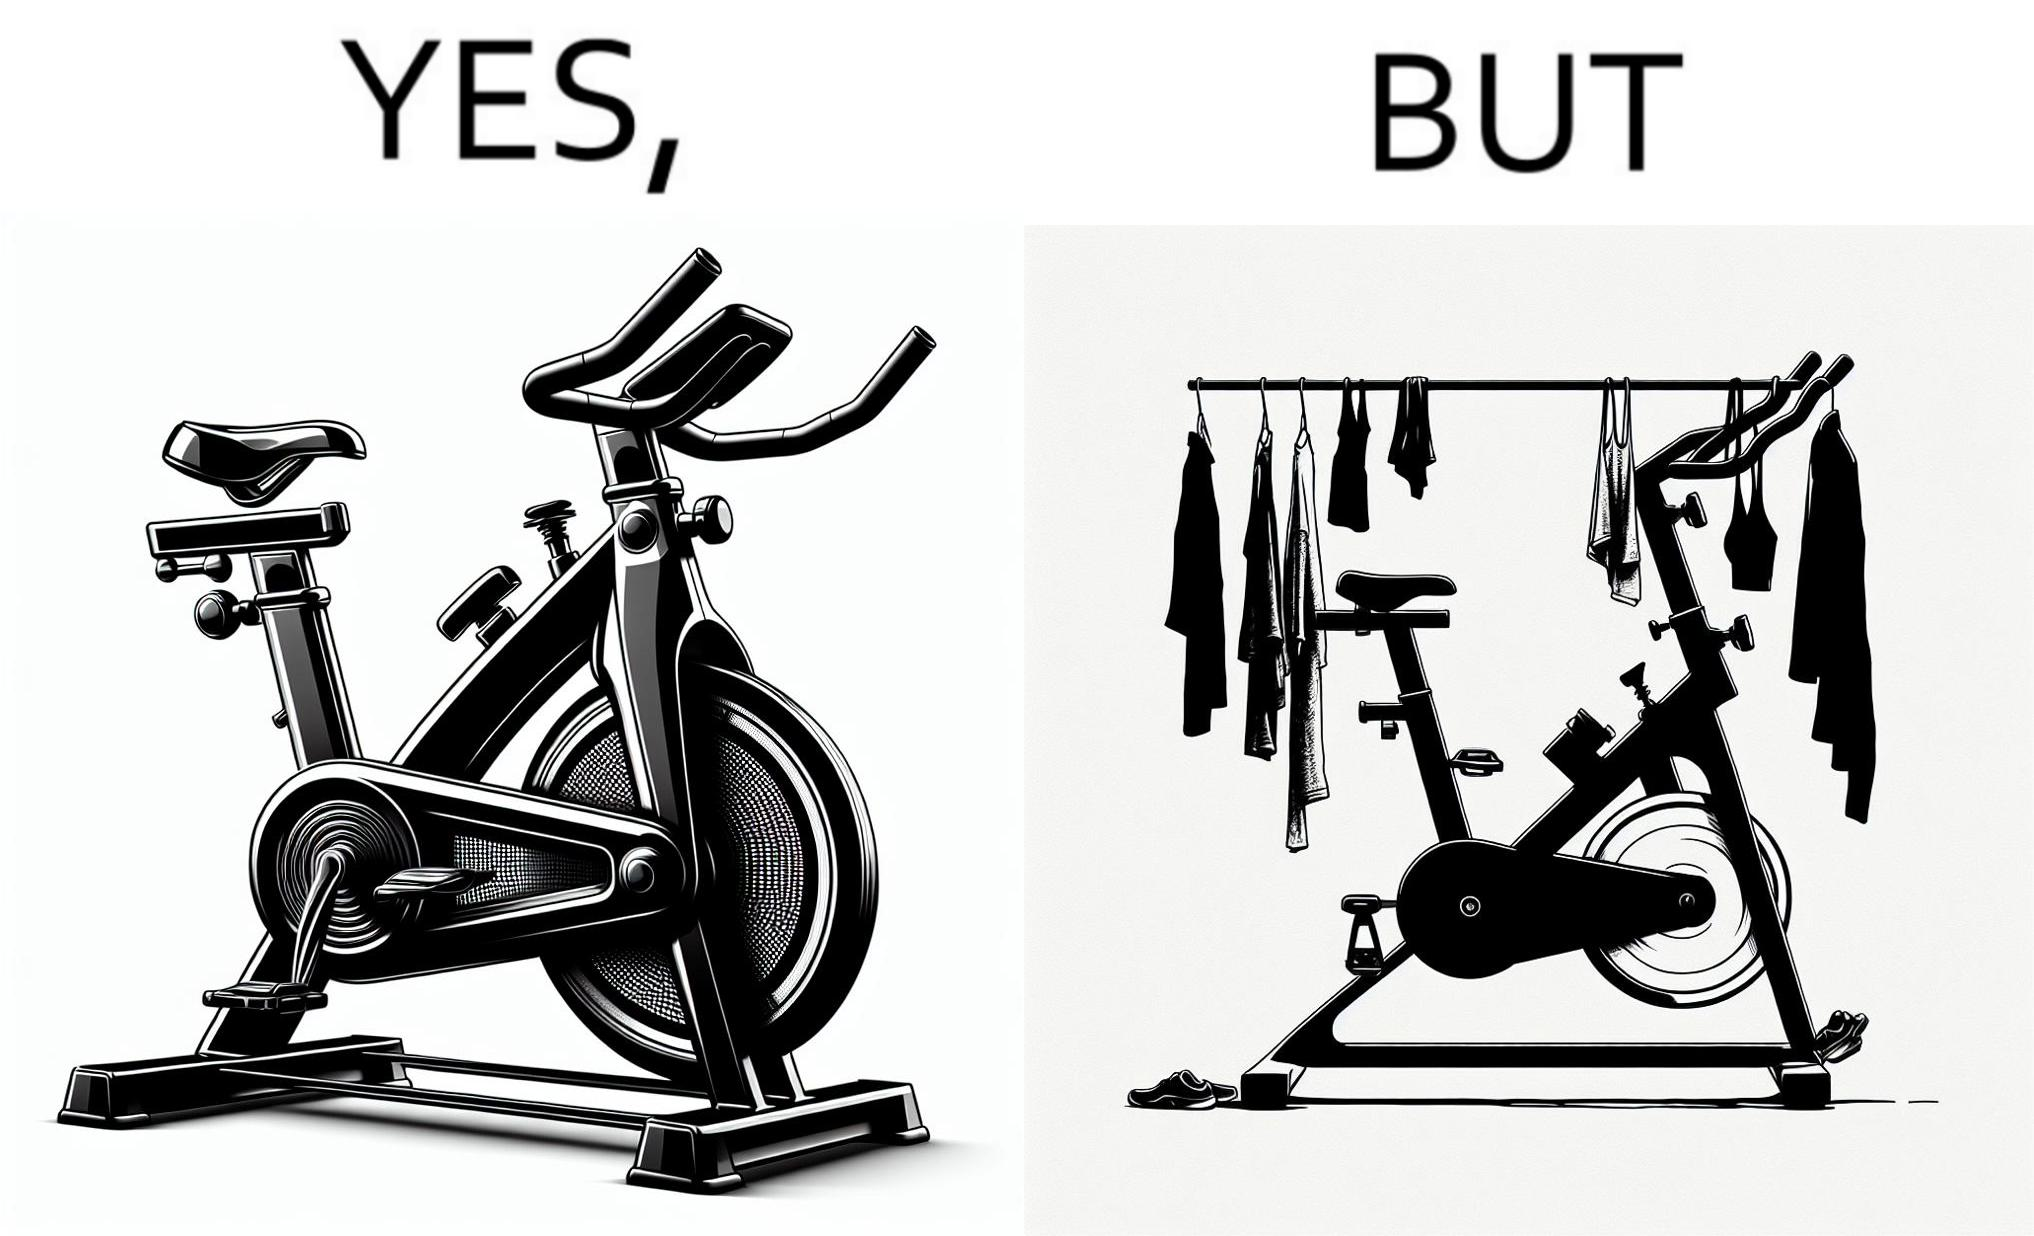Does this image contain satire or humor? Yes, this image is satirical. 